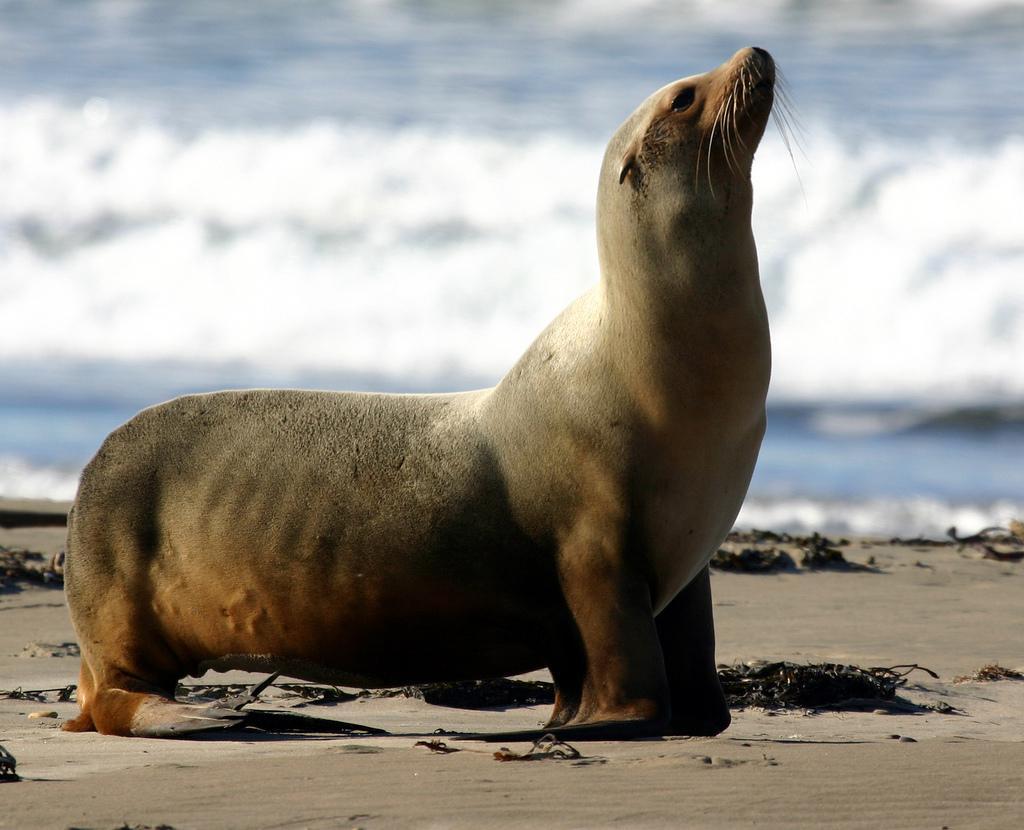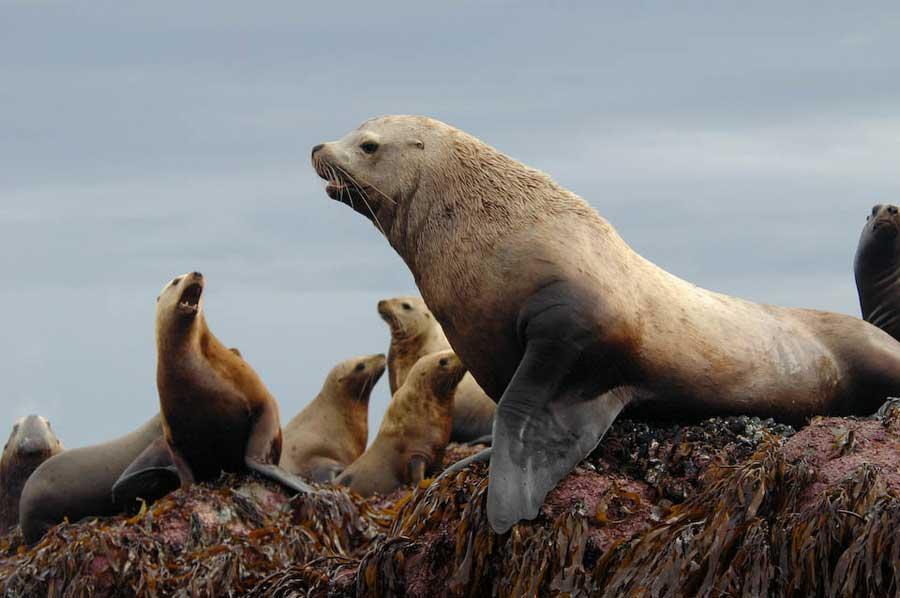The first image is the image on the left, the second image is the image on the right. Examine the images to the left and right. Is the description "One of the images is of a lone animal on a sandy beach." accurate? Answer yes or no. Yes. The first image is the image on the left, the second image is the image on the right. For the images shown, is this caption "One of the sea lions in on sand." true? Answer yes or no. Yes. 